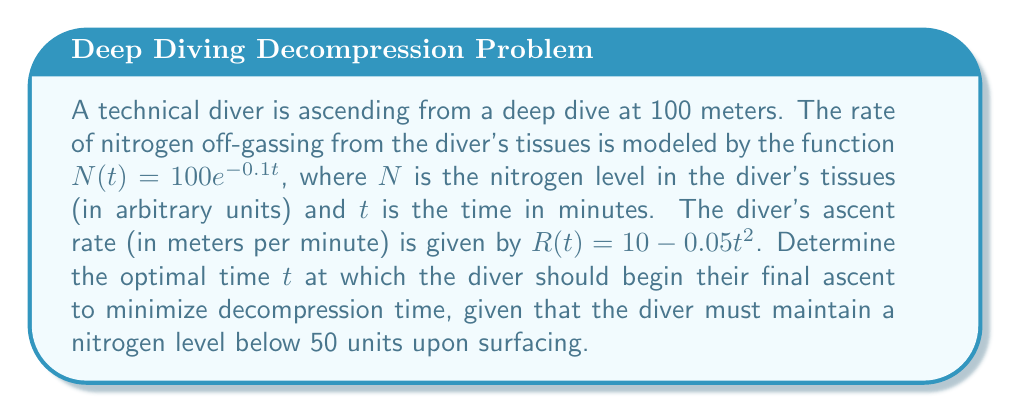Solve this math problem. To solve this problem, we'll follow these steps:

1) First, we need to find the time $t$ when the nitrogen level reaches 50 units:
   $N(t) = 50$
   $100e^{-0.1t} = 50$
   $e^{-0.1t} = 0.5$
   $-0.1t = \ln(0.5)$
   $t = -10\ln(0.5) \approx 6.93$ minutes

2) Now, we need to find the total distance traveled during this time:
   $D(t) = \int_0^t R(u) du = \int_0^t (10 - 0.05u^2) du$
   $D(t) = [10u - \frac{0.05u^3}{3}]_0^t = 10t - \frac{0.05t^3}{3}$

3) At $t \approx 6.93$ minutes, the distance traveled is:
   $D(6.93) = 10(6.93) - \frac{0.05(6.93)^3}{3} \approx 67.3$ meters

4) The remaining distance to surface is:
   $100 - 67.3 = 32.7$ meters

5) To minimize decompression time, the diver should begin their final ascent when the rate of ascent matches the remaining distance divided by the time left:
   $R(t) = \frac{32.7}{6.93 - t}$

6) Solving this equation:
   $10 - 0.05t^2 = \frac{32.7}{6.93 - t}$
   $(10 - 0.05t^2)(6.93 - t) = 32.7$
   $69.3 - 10t - 0.3465t^2 + 0.05t^3 = 32.7$
   $0.05t^3 - 0.3465t^2 - 10t + 36.6 = 0$

7) Solving this cubic equation numerically gives us $t \approx 4.18$ minutes.
Answer: $4.18$ minutes 